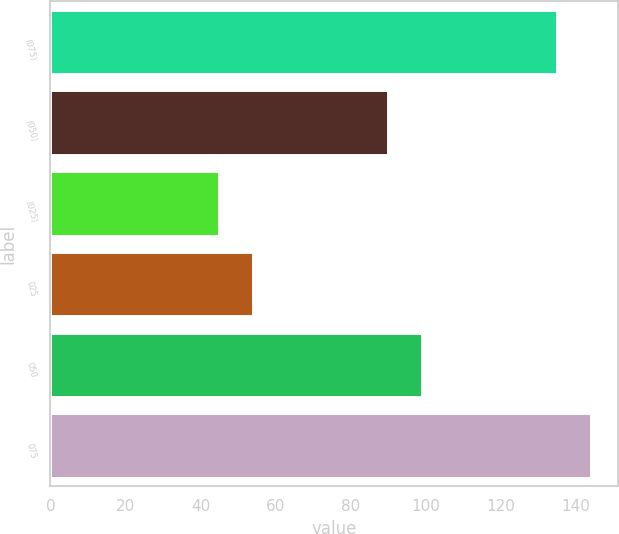Convert chart. <chart><loc_0><loc_0><loc_500><loc_500><bar_chart><fcel>(075)<fcel>(050)<fcel>(025)<fcel>025<fcel>050<fcel>075<nl><fcel>135<fcel>90<fcel>45<fcel>54<fcel>99<fcel>144<nl></chart> 